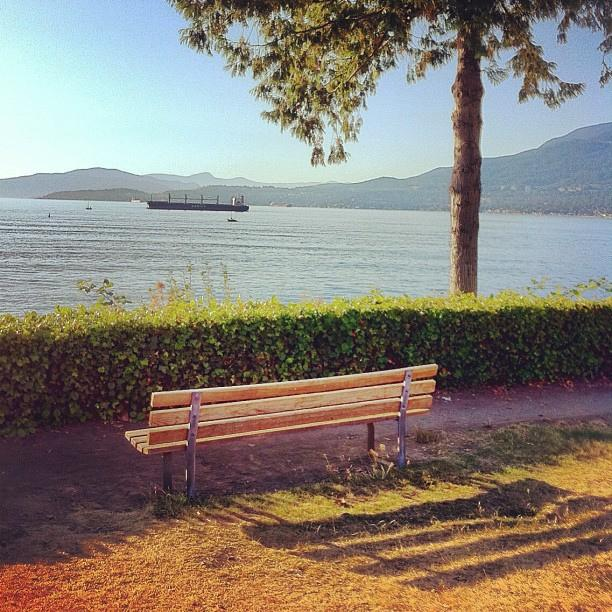What is casted on the ground behind the bench?

Choices:
A) doubt
B) shadow
C) mirror image
D) hole shadow 